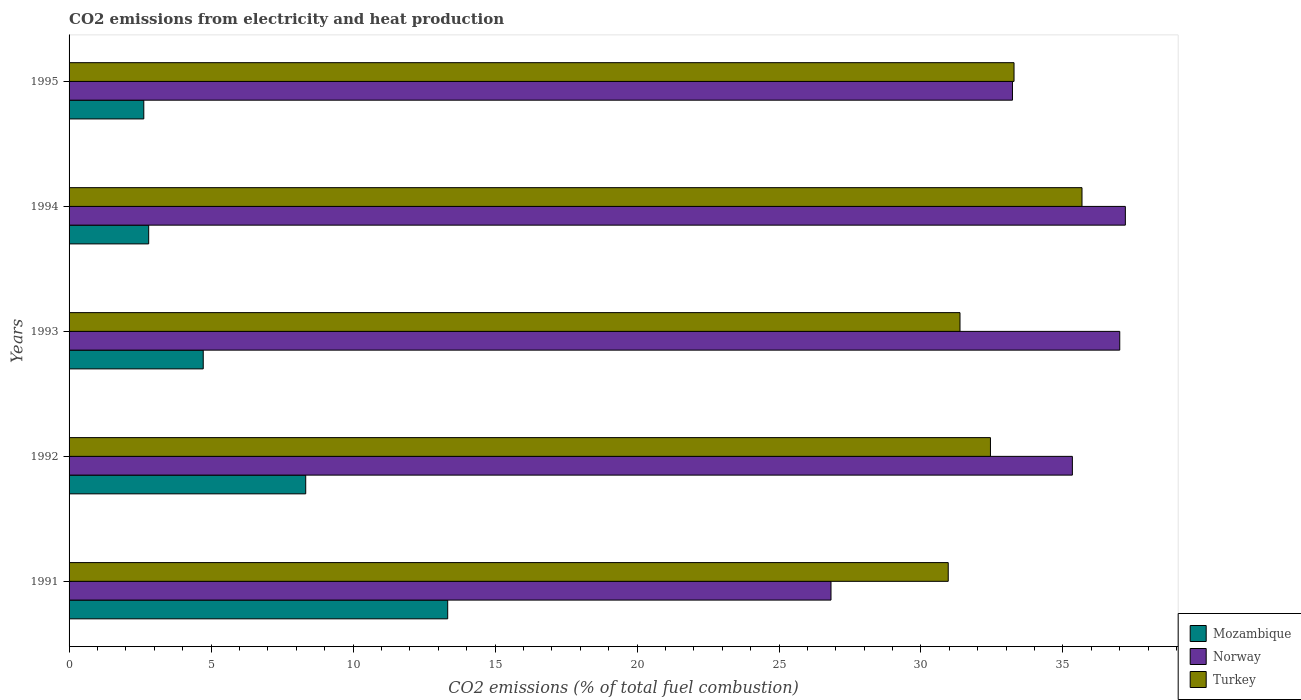Are the number of bars per tick equal to the number of legend labels?
Offer a terse response. Yes. How many bars are there on the 2nd tick from the top?
Offer a terse response. 3. How many bars are there on the 2nd tick from the bottom?
Offer a very short reply. 3. What is the label of the 2nd group of bars from the top?
Offer a very short reply. 1994. What is the amount of CO2 emitted in Norway in 1994?
Make the answer very short. 37.2. Across all years, what is the maximum amount of CO2 emitted in Mozambique?
Ensure brevity in your answer.  13.33. Across all years, what is the minimum amount of CO2 emitted in Turkey?
Make the answer very short. 30.96. In which year was the amount of CO2 emitted in Mozambique minimum?
Give a very brief answer. 1995. What is the total amount of CO2 emitted in Norway in the graph?
Make the answer very short. 169.58. What is the difference between the amount of CO2 emitted in Mozambique in 1992 and that in 1993?
Provide a succinct answer. 3.61. What is the difference between the amount of CO2 emitted in Norway in 1994 and the amount of CO2 emitted in Turkey in 1991?
Your response must be concise. 6.24. What is the average amount of CO2 emitted in Mozambique per year?
Your response must be concise. 6.37. In the year 1994, what is the difference between the amount of CO2 emitted in Turkey and amount of CO2 emitted in Mozambique?
Keep it short and to the point. 32.87. What is the ratio of the amount of CO2 emitted in Turkey in 1991 to that in 1992?
Keep it short and to the point. 0.95. What is the difference between the highest and the second highest amount of CO2 emitted in Turkey?
Make the answer very short. 2.39. What is the difference between the highest and the lowest amount of CO2 emitted in Turkey?
Your answer should be compact. 4.71. In how many years, is the amount of CO2 emitted in Mozambique greater than the average amount of CO2 emitted in Mozambique taken over all years?
Offer a very short reply. 2. Is the sum of the amount of CO2 emitted in Norway in 1992 and 1995 greater than the maximum amount of CO2 emitted in Mozambique across all years?
Offer a terse response. Yes. What does the 2nd bar from the top in 1993 represents?
Offer a terse response. Norway. Is it the case that in every year, the sum of the amount of CO2 emitted in Mozambique and amount of CO2 emitted in Norway is greater than the amount of CO2 emitted in Turkey?
Give a very brief answer. Yes. Where does the legend appear in the graph?
Provide a short and direct response. Bottom right. How are the legend labels stacked?
Give a very brief answer. Vertical. What is the title of the graph?
Provide a short and direct response. CO2 emissions from electricity and heat production. What is the label or title of the X-axis?
Your answer should be compact. CO2 emissions (% of total fuel combustion). What is the CO2 emissions (% of total fuel combustion) of Mozambique in 1991?
Your answer should be very brief. 13.33. What is the CO2 emissions (% of total fuel combustion) of Norway in 1991?
Provide a succinct answer. 26.83. What is the CO2 emissions (% of total fuel combustion) in Turkey in 1991?
Give a very brief answer. 30.96. What is the CO2 emissions (% of total fuel combustion) of Mozambique in 1992?
Your response must be concise. 8.33. What is the CO2 emissions (% of total fuel combustion) of Norway in 1992?
Your answer should be compact. 35.33. What is the CO2 emissions (% of total fuel combustion) in Turkey in 1992?
Offer a terse response. 32.45. What is the CO2 emissions (% of total fuel combustion) in Mozambique in 1993?
Provide a short and direct response. 4.72. What is the CO2 emissions (% of total fuel combustion) of Norway in 1993?
Your response must be concise. 37. What is the CO2 emissions (% of total fuel combustion) in Turkey in 1993?
Provide a succinct answer. 31.37. What is the CO2 emissions (% of total fuel combustion) in Mozambique in 1994?
Provide a short and direct response. 2.8. What is the CO2 emissions (% of total fuel combustion) in Norway in 1994?
Provide a short and direct response. 37.2. What is the CO2 emissions (% of total fuel combustion) in Turkey in 1994?
Provide a succinct answer. 35.67. What is the CO2 emissions (% of total fuel combustion) in Mozambique in 1995?
Keep it short and to the point. 2.63. What is the CO2 emissions (% of total fuel combustion) in Norway in 1995?
Your answer should be very brief. 33.22. What is the CO2 emissions (% of total fuel combustion) of Turkey in 1995?
Provide a short and direct response. 33.28. Across all years, what is the maximum CO2 emissions (% of total fuel combustion) in Mozambique?
Ensure brevity in your answer.  13.33. Across all years, what is the maximum CO2 emissions (% of total fuel combustion) in Norway?
Provide a short and direct response. 37.2. Across all years, what is the maximum CO2 emissions (% of total fuel combustion) of Turkey?
Your answer should be very brief. 35.67. Across all years, what is the minimum CO2 emissions (% of total fuel combustion) of Mozambique?
Provide a short and direct response. 2.63. Across all years, what is the minimum CO2 emissions (% of total fuel combustion) in Norway?
Your answer should be compact. 26.83. Across all years, what is the minimum CO2 emissions (% of total fuel combustion) in Turkey?
Keep it short and to the point. 30.96. What is the total CO2 emissions (% of total fuel combustion) in Mozambique in the graph?
Keep it short and to the point. 31.83. What is the total CO2 emissions (% of total fuel combustion) of Norway in the graph?
Provide a short and direct response. 169.58. What is the total CO2 emissions (% of total fuel combustion) in Turkey in the graph?
Make the answer very short. 163.73. What is the difference between the CO2 emissions (% of total fuel combustion) in Mozambique in 1991 and that in 1992?
Your response must be concise. 5. What is the difference between the CO2 emissions (% of total fuel combustion) in Norway in 1991 and that in 1992?
Your response must be concise. -8.5. What is the difference between the CO2 emissions (% of total fuel combustion) in Turkey in 1991 and that in 1992?
Your response must be concise. -1.49. What is the difference between the CO2 emissions (% of total fuel combustion) of Mozambique in 1991 and that in 1993?
Ensure brevity in your answer.  8.61. What is the difference between the CO2 emissions (% of total fuel combustion) of Norway in 1991 and that in 1993?
Provide a succinct answer. -10.17. What is the difference between the CO2 emissions (% of total fuel combustion) of Turkey in 1991 and that in 1993?
Provide a short and direct response. -0.41. What is the difference between the CO2 emissions (% of total fuel combustion) of Mozambique in 1991 and that in 1994?
Ensure brevity in your answer.  10.53. What is the difference between the CO2 emissions (% of total fuel combustion) in Norway in 1991 and that in 1994?
Offer a very short reply. -10.37. What is the difference between the CO2 emissions (% of total fuel combustion) in Turkey in 1991 and that in 1994?
Your answer should be compact. -4.71. What is the difference between the CO2 emissions (% of total fuel combustion) of Mozambique in 1991 and that in 1995?
Give a very brief answer. 10.7. What is the difference between the CO2 emissions (% of total fuel combustion) of Norway in 1991 and that in 1995?
Ensure brevity in your answer.  -6.39. What is the difference between the CO2 emissions (% of total fuel combustion) of Turkey in 1991 and that in 1995?
Provide a short and direct response. -2.32. What is the difference between the CO2 emissions (% of total fuel combustion) of Mozambique in 1992 and that in 1993?
Give a very brief answer. 3.61. What is the difference between the CO2 emissions (% of total fuel combustion) of Norway in 1992 and that in 1993?
Give a very brief answer. -1.67. What is the difference between the CO2 emissions (% of total fuel combustion) of Turkey in 1992 and that in 1993?
Give a very brief answer. 1.07. What is the difference between the CO2 emissions (% of total fuel combustion) in Mozambique in 1992 and that in 1994?
Offer a terse response. 5.53. What is the difference between the CO2 emissions (% of total fuel combustion) in Norway in 1992 and that in 1994?
Ensure brevity in your answer.  -1.87. What is the difference between the CO2 emissions (% of total fuel combustion) in Turkey in 1992 and that in 1994?
Your answer should be very brief. -3.22. What is the difference between the CO2 emissions (% of total fuel combustion) in Mozambique in 1992 and that in 1995?
Offer a very short reply. 5.7. What is the difference between the CO2 emissions (% of total fuel combustion) of Norway in 1992 and that in 1995?
Provide a short and direct response. 2.11. What is the difference between the CO2 emissions (% of total fuel combustion) in Turkey in 1992 and that in 1995?
Make the answer very short. -0.83. What is the difference between the CO2 emissions (% of total fuel combustion) in Mozambique in 1993 and that in 1994?
Ensure brevity in your answer.  1.92. What is the difference between the CO2 emissions (% of total fuel combustion) in Norway in 1993 and that in 1994?
Keep it short and to the point. -0.2. What is the difference between the CO2 emissions (% of total fuel combustion) in Turkey in 1993 and that in 1994?
Provide a succinct answer. -4.3. What is the difference between the CO2 emissions (% of total fuel combustion) of Mozambique in 1993 and that in 1995?
Provide a short and direct response. 2.09. What is the difference between the CO2 emissions (% of total fuel combustion) of Norway in 1993 and that in 1995?
Provide a succinct answer. 3.78. What is the difference between the CO2 emissions (% of total fuel combustion) of Turkey in 1993 and that in 1995?
Keep it short and to the point. -1.9. What is the difference between the CO2 emissions (% of total fuel combustion) in Mozambique in 1994 and that in 1995?
Your answer should be compact. 0.17. What is the difference between the CO2 emissions (% of total fuel combustion) in Norway in 1994 and that in 1995?
Your answer should be compact. 3.98. What is the difference between the CO2 emissions (% of total fuel combustion) in Turkey in 1994 and that in 1995?
Provide a succinct answer. 2.39. What is the difference between the CO2 emissions (% of total fuel combustion) in Mozambique in 1991 and the CO2 emissions (% of total fuel combustion) in Norway in 1992?
Your answer should be very brief. -22. What is the difference between the CO2 emissions (% of total fuel combustion) in Mozambique in 1991 and the CO2 emissions (% of total fuel combustion) in Turkey in 1992?
Make the answer very short. -19.11. What is the difference between the CO2 emissions (% of total fuel combustion) of Norway in 1991 and the CO2 emissions (% of total fuel combustion) of Turkey in 1992?
Ensure brevity in your answer.  -5.62. What is the difference between the CO2 emissions (% of total fuel combustion) of Mozambique in 1991 and the CO2 emissions (% of total fuel combustion) of Norway in 1993?
Your answer should be compact. -23.67. What is the difference between the CO2 emissions (% of total fuel combustion) in Mozambique in 1991 and the CO2 emissions (% of total fuel combustion) in Turkey in 1993?
Offer a very short reply. -18.04. What is the difference between the CO2 emissions (% of total fuel combustion) of Norway in 1991 and the CO2 emissions (% of total fuel combustion) of Turkey in 1993?
Offer a very short reply. -4.54. What is the difference between the CO2 emissions (% of total fuel combustion) in Mozambique in 1991 and the CO2 emissions (% of total fuel combustion) in Norway in 1994?
Give a very brief answer. -23.86. What is the difference between the CO2 emissions (% of total fuel combustion) of Mozambique in 1991 and the CO2 emissions (% of total fuel combustion) of Turkey in 1994?
Offer a terse response. -22.34. What is the difference between the CO2 emissions (% of total fuel combustion) of Norway in 1991 and the CO2 emissions (% of total fuel combustion) of Turkey in 1994?
Your answer should be compact. -8.84. What is the difference between the CO2 emissions (% of total fuel combustion) in Mozambique in 1991 and the CO2 emissions (% of total fuel combustion) in Norway in 1995?
Ensure brevity in your answer.  -19.89. What is the difference between the CO2 emissions (% of total fuel combustion) of Mozambique in 1991 and the CO2 emissions (% of total fuel combustion) of Turkey in 1995?
Give a very brief answer. -19.94. What is the difference between the CO2 emissions (% of total fuel combustion) of Norway in 1991 and the CO2 emissions (% of total fuel combustion) of Turkey in 1995?
Ensure brevity in your answer.  -6.45. What is the difference between the CO2 emissions (% of total fuel combustion) in Mozambique in 1992 and the CO2 emissions (% of total fuel combustion) in Norway in 1993?
Your answer should be compact. -28.67. What is the difference between the CO2 emissions (% of total fuel combustion) of Mozambique in 1992 and the CO2 emissions (% of total fuel combustion) of Turkey in 1993?
Ensure brevity in your answer.  -23.04. What is the difference between the CO2 emissions (% of total fuel combustion) of Norway in 1992 and the CO2 emissions (% of total fuel combustion) of Turkey in 1993?
Ensure brevity in your answer.  3.96. What is the difference between the CO2 emissions (% of total fuel combustion) of Mozambique in 1992 and the CO2 emissions (% of total fuel combustion) of Norway in 1994?
Ensure brevity in your answer.  -28.86. What is the difference between the CO2 emissions (% of total fuel combustion) in Mozambique in 1992 and the CO2 emissions (% of total fuel combustion) in Turkey in 1994?
Your answer should be very brief. -27.34. What is the difference between the CO2 emissions (% of total fuel combustion) in Norway in 1992 and the CO2 emissions (% of total fuel combustion) in Turkey in 1994?
Give a very brief answer. -0.34. What is the difference between the CO2 emissions (% of total fuel combustion) in Mozambique in 1992 and the CO2 emissions (% of total fuel combustion) in Norway in 1995?
Ensure brevity in your answer.  -24.89. What is the difference between the CO2 emissions (% of total fuel combustion) in Mozambique in 1992 and the CO2 emissions (% of total fuel combustion) in Turkey in 1995?
Ensure brevity in your answer.  -24.94. What is the difference between the CO2 emissions (% of total fuel combustion) of Norway in 1992 and the CO2 emissions (% of total fuel combustion) of Turkey in 1995?
Make the answer very short. 2.06. What is the difference between the CO2 emissions (% of total fuel combustion) of Mozambique in 1993 and the CO2 emissions (% of total fuel combustion) of Norway in 1994?
Provide a succinct answer. -32.47. What is the difference between the CO2 emissions (% of total fuel combustion) in Mozambique in 1993 and the CO2 emissions (% of total fuel combustion) in Turkey in 1994?
Provide a short and direct response. -30.95. What is the difference between the CO2 emissions (% of total fuel combustion) of Norway in 1993 and the CO2 emissions (% of total fuel combustion) of Turkey in 1994?
Offer a terse response. 1.33. What is the difference between the CO2 emissions (% of total fuel combustion) in Mozambique in 1993 and the CO2 emissions (% of total fuel combustion) in Norway in 1995?
Offer a very short reply. -28.5. What is the difference between the CO2 emissions (% of total fuel combustion) of Mozambique in 1993 and the CO2 emissions (% of total fuel combustion) of Turkey in 1995?
Make the answer very short. -28.55. What is the difference between the CO2 emissions (% of total fuel combustion) of Norway in 1993 and the CO2 emissions (% of total fuel combustion) of Turkey in 1995?
Ensure brevity in your answer.  3.72. What is the difference between the CO2 emissions (% of total fuel combustion) of Mozambique in 1994 and the CO2 emissions (% of total fuel combustion) of Norway in 1995?
Keep it short and to the point. -30.42. What is the difference between the CO2 emissions (% of total fuel combustion) in Mozambique in 1994 and the CO2 emissions (% of total fuel combustion) in Turkey in 1995?
Offer a terse response. -30.47. What is the difference between the CO2 emissions (% of total fuel combustion) of Norway in 1994 and the CO2 emissions (% of total fuel combustion) of Turkey in 1995?
Provide a succinct answer. 3.92. What is the average CO2 emissions (% of total fuel combustion) in Mozambique per year?
Give a very brief answer. 6.37. What is the average CO2 emissions (% of total fuel combustion) of Norway per year?
Your answer should be compact. 33.92. What is the average CO2 emissions (% of total fuel combustion) in Turkey per year?
Give a very brief answer. 32.75. In the year 1991, what is the difference between the CO2 emissions (% of total fuel combustion) of Mozambique and CO2 emissions (% of total fuel combustion) of Norway?
Your answer should be compact. -13.5. In the year 1991, what is the difference between the CO2 emissions (% of total fuel combustion) of Mozambique and CO2 emissions (% of total fuel combustion) of Turkey?
Provide a short and direct response. -17.63. In the year 1991, what is the difference between the CO2 emissions (% of total fuel combustion) of Norway and CO2 emissions (% of total fuel combustion) of Turkey?
Your response must be concise. -4.13. In the year 1992, what is the difference between the CO2 emissions (% of total fuel combustion) in Mozambique and CO2 emissions (% of total fuel combustion) in Norway?
Provide a short and direct response. -27. In the year 1992, what is the difference between the CO2 emissions (% of total fuel combustion) of Mozambique and CO2 emissions (% of total fuel combustion) of Turkey?
Make the answer very short. -24.11. In the year 1992, what is the difference between the CO2 emissions (% of total fuel combustion) of Norway and CO2 emissions (% of total fuel combustion) of Turkey?
Give a very brief answer. 2.89. In the year 1993, what is the difference between the CO2 emissions (% of total fuel combustion) in Mozambique and CO2 emissions (% of total fuel combustion) in Norway?
Give a very brief answer. -32.27. In the year 1993, what is the difference between the CO2 emissions (% of total fuel combustion) of Mozambique and CO2 emissions (% of total fuel combustion) of Turkey?
Provide a short and direct response. -26.65. In the year 1993, what is the difference between the CO2 emissions (% of total fuel combustion) in Norway and CO2 emissions (% of total fuel combustion) in Turkey?
Offer a terse response. 5.63. In the year 1994, what is the difference between the CO2 emissions (% of total fuel combustion) in Mozambique and CO2 emissions (% of total fuel combustion) in Norway?
Make the answer very short. -34.39. In the year 1994, what is the difference between the CO2 emissions (% of total fuel combustion) in Mozambique and CO2 emissions (% of total fuel combustion) in Turkey?
Give a very brief answer. -32.87. In the year 1994, what is the difference between the CO2 emissions (% of total fuel combustion) of Norway and CO2 emissions (% of total fuel combustion) of Turkey?
Make the answer very short. 1.53. In the year 1995, what is the difference between the CO2 emissions (% of total fuel combustion) in Mozambique and CO2 emissions (% of total fuel combustion) in Norway?
Offer a very short reply. -30.59. In the year 1995, what is the difference between the CO2 emissions (% of total fuel combustion) in Mozambique and CO2 emissions (% of total fuel combustion) in Turkey?
Your response must be concise. -30.64. In the year 1995, what is the difference between the CO2 emissions (% of total fuel combustion) of Norway and CO2 emissions (% of total fuel combustion) of Turkey?
Your answer should be compact. -0.06. What is the ratio of the CO2 emissions (% of total fuel combustion) in Norway in 1991 to that in 1992?
Make the answer very short. 0.76. What is the ratio of the CO2 emissions (% of total fuel combustion) of Turkey in 1991 to that in 1992?
Provide a succinct answer. 0.95. What is the ratio of the CO2 emissions (% of total fuel combustion) of Mozambique in 1991 to that in 1993?
Your answer should be very brief. 2.82. What is the ratio of the CO2 emissions (% of total fuel combustion) of Norway in 1991 to that in 1993?
Your response must be concise. 0.73. What is the ratio of the CO2 emissions (% of total fuel combustion) in Mozambique in 1991 to that in 1994?
Your answer should be very brief. 4.76. What is the ratio of the CO2 emissions (% of total fuel combustion) of Norway in 1991 to that in 1994?
Give a very brief answer. 0.72. What is the ratio of the CO2 emissions (% of total fuel combustion) of Turkey in 1991 to that in 1994?
Offer a very short reply. 0.87. What is the ratio of the CO2 emissions (% of total fuel combustion) of Mozambique in 1991 to that in 1995?
Your answer should be compact. 5.07. What is the ratio of the CO2 emissions (% of total fuel combustion) in Norway in 1991 to that in 1995?
Offer a very short reply. 0.81. What is the ratio of the CO2 emissions (% of total fuel combustion) of Turkey in 1991 to that in 1995?
Give a very brief answer. 0.93. What is the ratio of the CO2 emissions (% of total fuel combustion) of Mozambique in 1992 to that in 1993?
Ensure brevity in your answer.  1.76. What is the ratio of the CO2 emissions (% of total fuel combustion) in Norway in 1992 to that in 1993?
Give a very brief answer. 0.95. What is the ratio of the CO2 emissions (% of total fuel combustion) of Turkey in 1992 to that in 1993?
Offer a very short reply. 1.03. What is the ratio of the CO2 emissions (% of total fuel combustion) of Mozambique in 1992 to that in 1994?
Your answer should be very brief. 2.97. What is the ratio of the CO2 emissions (% of total fuel combustion) in Norway in 1992 to that in 1994?
Ensure brevity in your answer.  0.95. What is the ratio of the CO2 emissions (% of total fuel combustion) of Turkey in 1992 to that in 1994?
Make the answer very short. 0.91. What is the ratio of the CO2 emissions (% of total fuel combustion) of Mozambique in 1992 to that in 1995?
Your answer should be very brief. 3.17. What is the ratio of the CO2 emissions (% of total fuel combustion) in Norway in 1992 to that in 1995?
Ensure brevity in your answer.  1.06. What is the ratio of the CO2 emissions (% of total fuel combustion) of Turkey in 1992 to that in 1995?
Your answer should be very brief. 0.98. What is the ratio of the CO2 emissions (% of total fuel combustion) in Mozambique in 1993 to that in 1994?
Make the answer very short. 1.69. What is the ratio of the CO2 emissions (% of total fuel combustion) of Turkey in 1993 to that in 1994?
Ensure brevity in your answer.  0.88. What is the ratio of the CO2 emissions (% of total fuel combustion) of Mozambique in 1993 to that in 1995?
Your response must be concise. 1.8. What is the ratio of the CO2 emissions (% of total fuel combustion) in Norway in 1993 to that in 1995?
Offer a terse response. 1.11. What is the ratio of the CO2 emissions (% of total fuel combustion) in Turkey in 1993 to that in 1995?
Your answer should be compact. 0.94. What is the ratio of the CO2 emissions (% of total fuel combustion) in Mozambique in 1994 to that in 1995?
Give a very brief answer. 1.07. What is the ratio of the CO2 emissions (% of total fuel combustion) of Norway in 1994 to that in 1995?
Offer a very short reply. 1.12. What is the ratio of the CO2 emissions (% of total fuel combustion) of Turkey in 1994 to that in 1995?
Ensure brevity in your answer.  1.07. What is the difference between the highest and the second highest CO2 emissions (% of total fuel combustion) in Norway?
Offer a very short reply. 0.2. What is the difference between the highest and the second highest CO2 emissions (% of total fuel combustion) in Turkey?
Offer a terse response. 2.39. What is the difference between the highest and the lowest CO2 emissions (% of total fuel combustion) in Mozambique?
Make the answer very short. 10.7. What is the difference between the highest and the lowest CO2 emissions (% of total fuel combustion) in Norway?
Offer a very short reply. 10.37. What is the difference between the highest and the lowest CO2 emissions (% of total fuel combustion) in Turkey?
Provide a succinct answer. 4.71. 